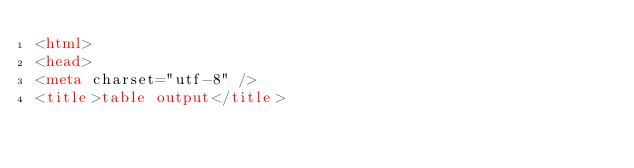<code> <loc_0><loc_0><loc_500><loc_500><_HTML_><html>
<head>
<meta charset="utf-8" />
<title>table output</title></code> 